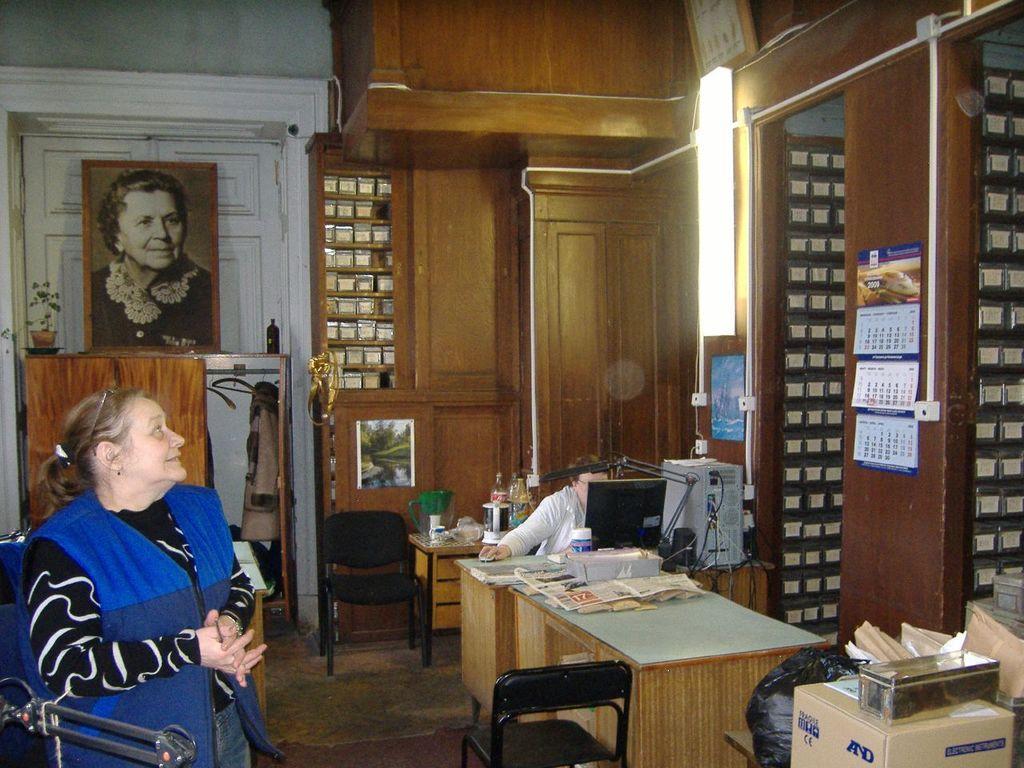How would you summarize this image in a sentence or two? In this picture, we see women in black t-shirt, is wearing blue jacket. Behind her, we see a door which is white in color and we see a photo frame of a woman placed on table. Beside that, we see cupboard which is brown in color and in and in the middle of the picture, we see table on which newspaper, water bottle, monitor and mouse are placed. In front of system, we see women in white jacket is sitting and operating it. Beside her, we even see CPU. On the right corner of the picture, we see a wall which is brown in color and on wall, we see calendar. On the right bottom of the picture, we see a cotton box. 